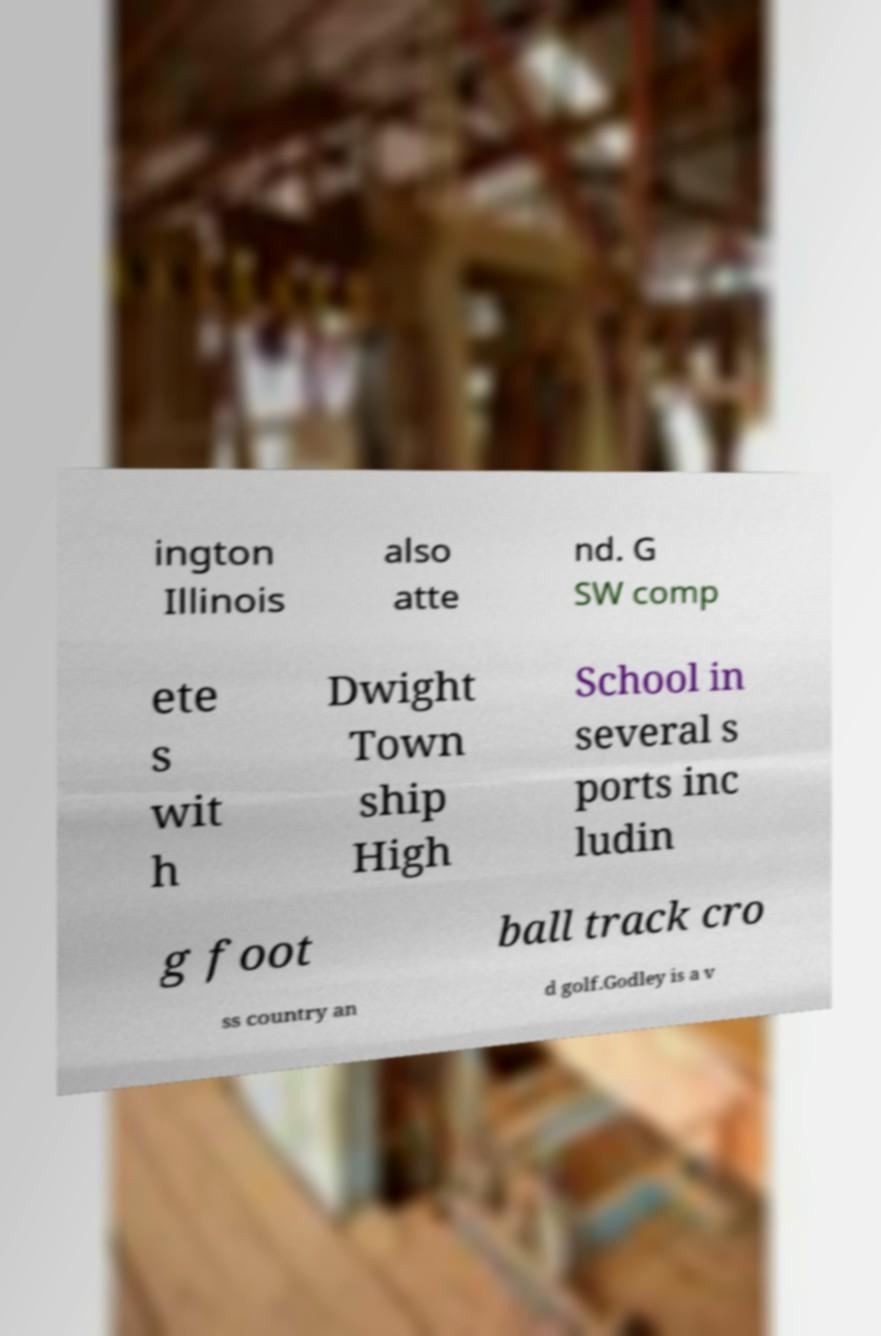For documentation purposes, I need the text within this image transcribed. Could you provide that? ington Illinois also atte nd. G SW comp ete s wit h Dwight Town ship High School in several s ports inc ludin g foot ball track cro ss country an d golf.Godley is a v 